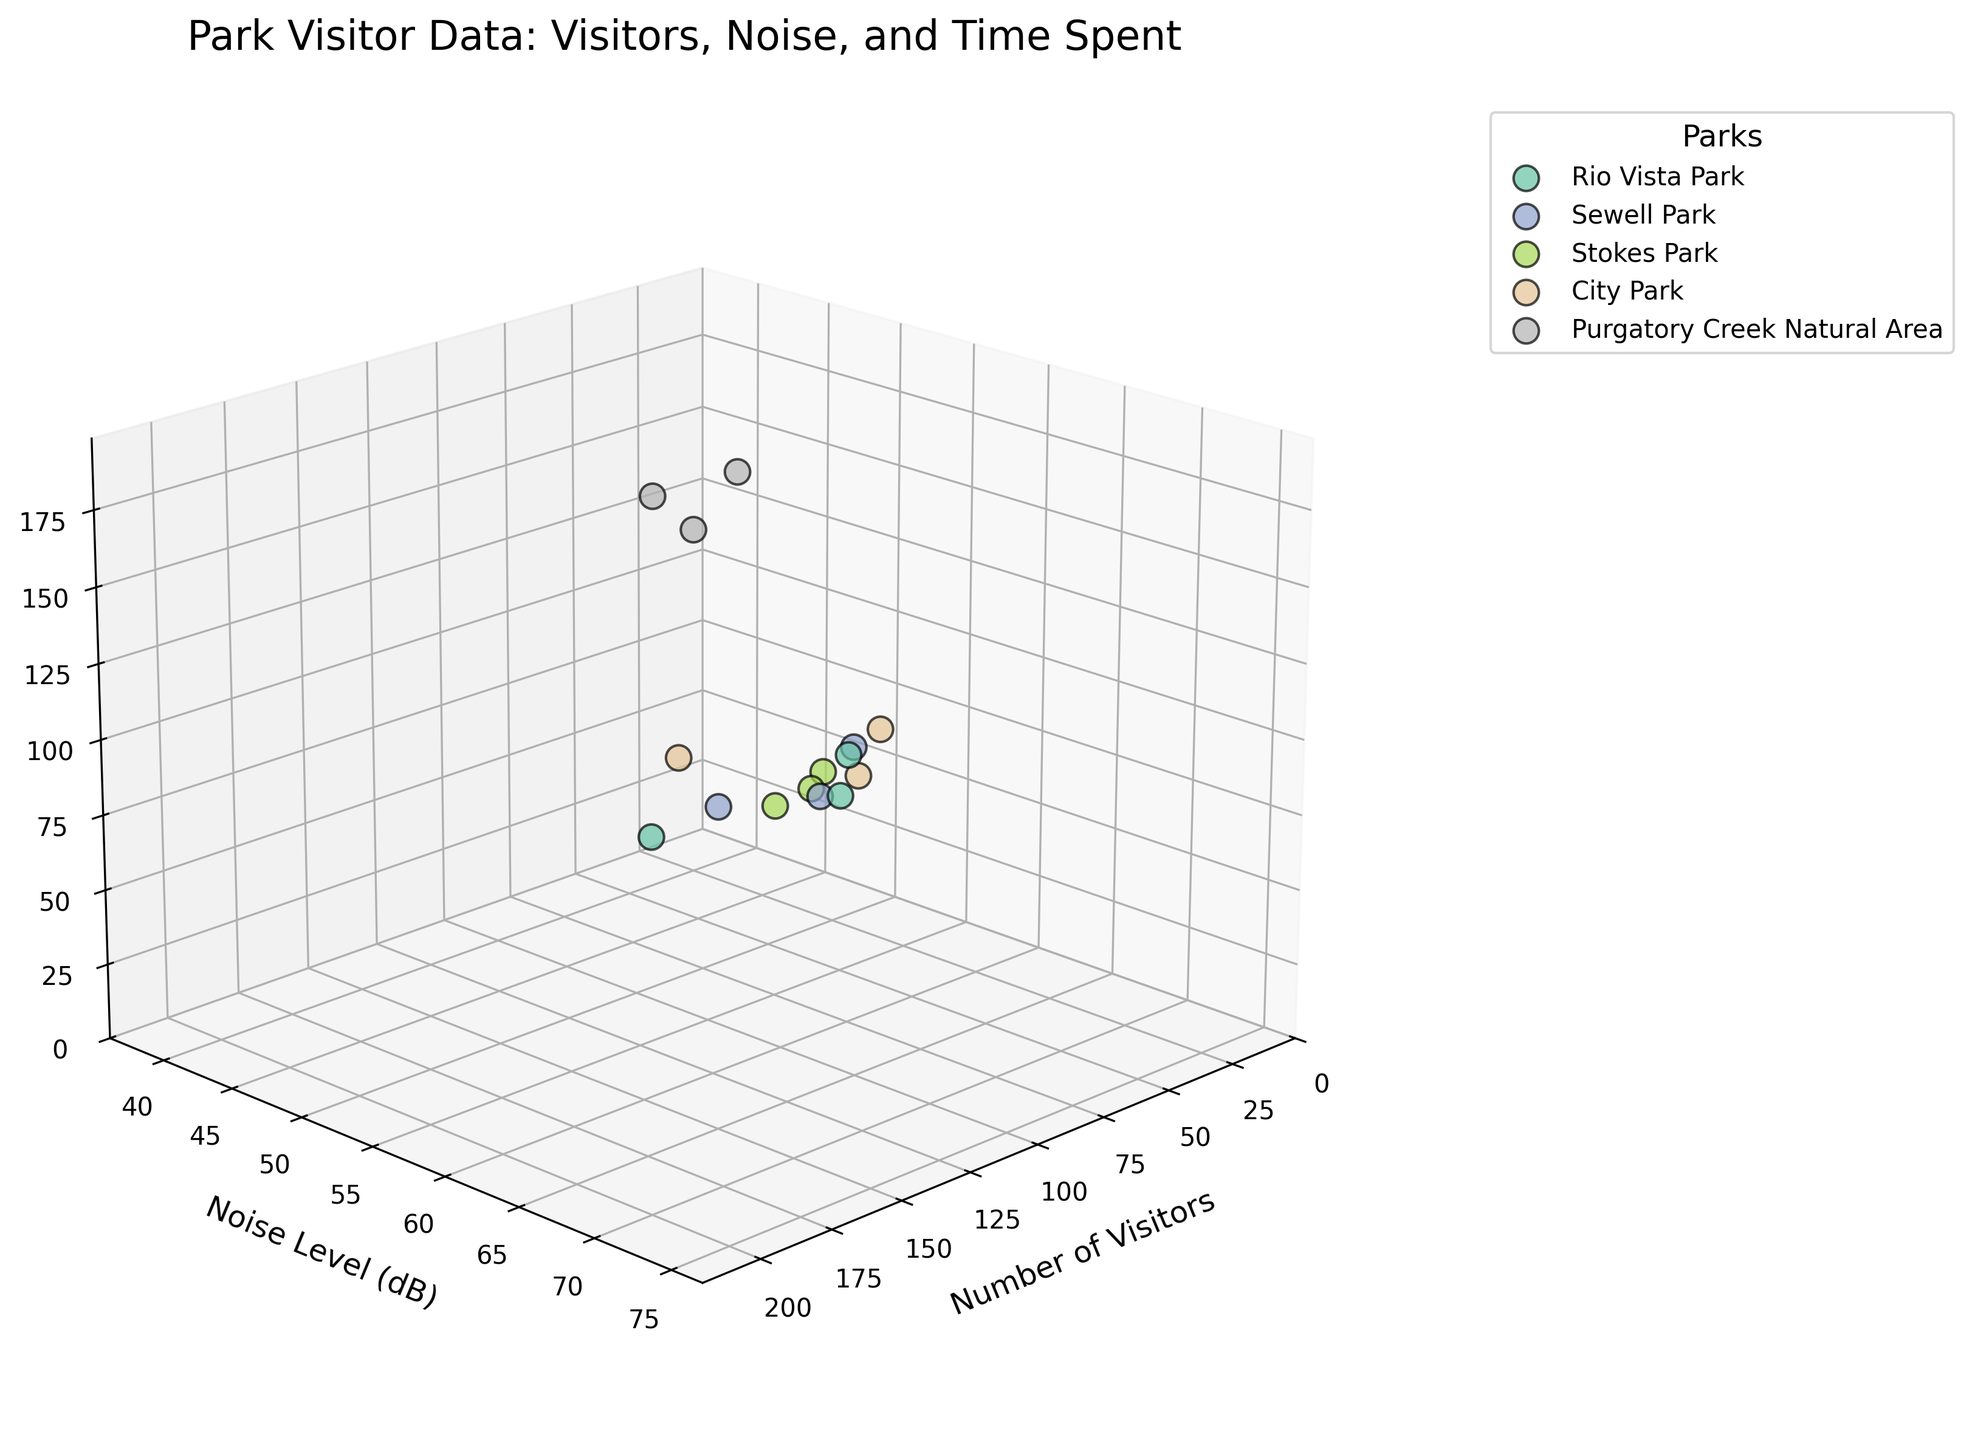How many parks are represented in the plot? Count the unique labels corresponding to different parks. Each unique label represents a different park.
Answer: 5 Which park has the highest number of visitors on any given day? Identify the data point with the highest value on the 'Number of Visitors' axis and note which park it belongs to.
Answer: Rio Vista Park On which days does Stokes Park have lower noise levels compared to Sewell Park? Compare the values on the 'Noise Level (dB)' axis for Stokes Park and Sewell Park on each day they appear in the dataset. Find the days where Stokes Park has a lower value.
Answer: Monday and Friday Which park has the longest time spent in minutes on a Saturday? Locate the data points corresponding to Saturday and compare the values on the 'Time Spent (minutes)' axis. Identify the park with the highest value.
Answer: Purgatory Creek Natural Area Is City Park noisier on a Sunday compared to Sewell Park on a Tuesday? Identify the noise levels (dB) for City Park on Sunday and Sewell Park on Tuesday, then compare these values.
Answer: Yes Calculate the average time spent at Rio Vista Park over the week. Sum the 'Time Spent (minutes)' values for Rio Vista Park across all days and divide by the number of data points for that park.
Answer: 90 minutes Which day has the lowest visitor count across all parks? Identify the data point with the minimum value on the 'Number of Visitors' axis, and note the corresponding day.
Answer: Monday Compare the number of visitors at Purgatory Creek Natural Area on Tuesday versus Thursday. Which day is higher? Locate the data points for Purgatory Creek Natural Area on Tuesday and Thursday and compare the 'Number of Visitors' values.
Answer: Thursday What is the noise level range observed in the plot? Find the minimum and maximum values on the 'Noise Level (dB)' axis to determine the range.
Answer: 40 to 70 dB Which park has the highest time spent on the weekend (Saturday and Sunday)? Sum the 'Time Spent (minutes)' values for each park on Saturday and Sunday separately, then compare the total values to identify the highest one.
Answer: Purgatory Creek Natural Area 